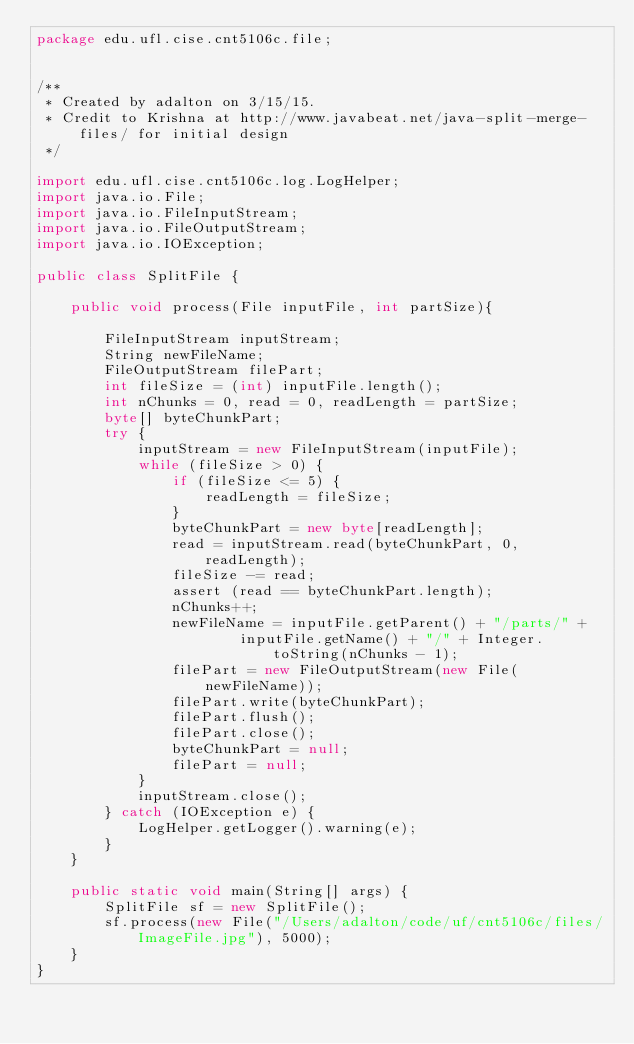Convert code to text. <code><loc_0><loc_0><loc_500><loc_500><_Java_>package edu.ufl.cise.cnt5106c.file;


/**
 * Created by adalton on 3/15/15.
 * Credit to Krishna at http://www.javabeat.net/java-split-merge-files/ for initial design
 */

import edu.ufl.cise.cnt5106c.log.LogHelper;
import java.io.File;
import java.io.FileInputStream;
import java.io.FileOutputStream;
import java.io.IOException;

public class SplitFile {

    public void process(File inputFile, int partSize){

        FileInputStream inputStream;
        String newFileName;
        FileOutputStream filePart;
        int fileSize = (int) inputFile.length();
        int nChunks = 0, read = 0, readLength = partSize;
        byte[] byteChunkPart;
        try {
            inputStream = new FileInputStream(inputFile);
            while (fileSize > 0) {
                if (fileSize <= 5) {
                    readLength = fileSize;
                }
                byteChunkPart = new byte[readLength];
                read = inputStream.read(byteChunkPart, 0, readLength);
                fileSize -= read;
                assert (read == byteChunkPart.length);
                nChunks++;
                newFileName = inputFile.getParent() + "/parts/" +
                        inputFile.getName() + "/" + Integer.toString(nChunks - 1);
                filePart = new FileOutputStream(new File(newFileName));
                filePart.write(byteChunkPart);
                filePart.flush();
                filePart.close();
                byteChunkPart = null;
                filePart = null;
            }
            inputStream.close();
        } catch (IOException e) {
            LogHelper.getLogger().warning(e);
        }
    }

    public static void main(String[] args) {
        SplitFile sf = new SplitFile();
        sf.process(new File("/Users/adalton/code/uf/cnt5106c/files/ImageFile.jpg"), 5000);
    }
}</code> 